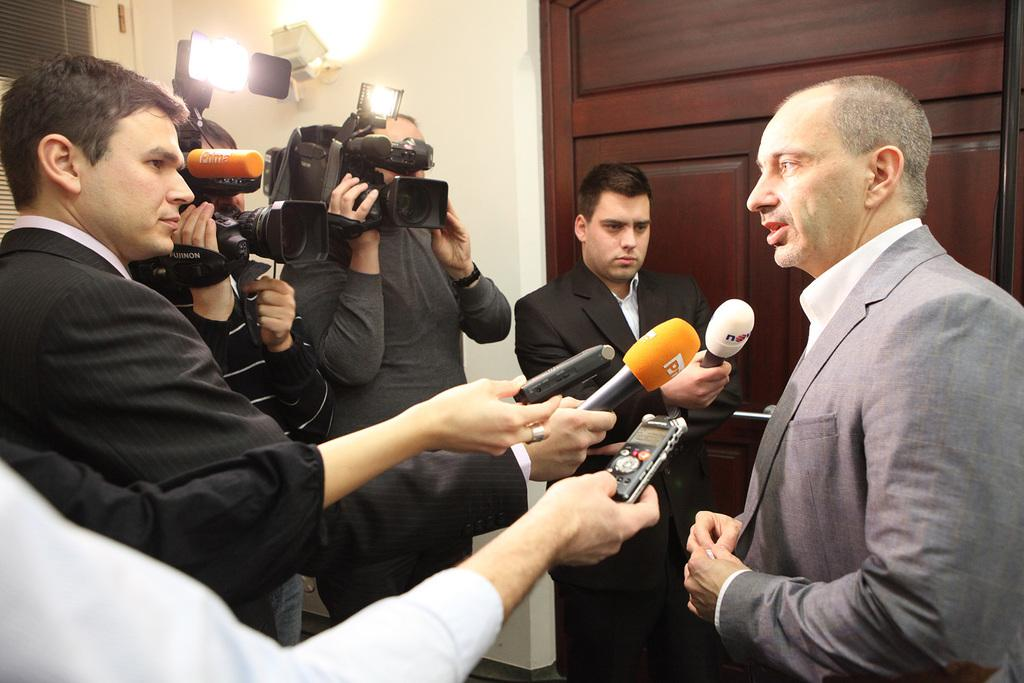What is the main subject of the image? There is a group of people in the image. Can you describe the man standing at the left side of the image? The man is standing at the left side of the image and is holding a microphone. What can be seen in the background of the image? There is a camera and a wall visible in the background of the image. What type of wilderness can be seen in the background of the image? There is no wilderness present in the image; the background features a wall and a camera. How does the group of people interact with the space in the image? The image does not depict any interaction with space, as it is a group of people in a setting with a wall and a camera. 